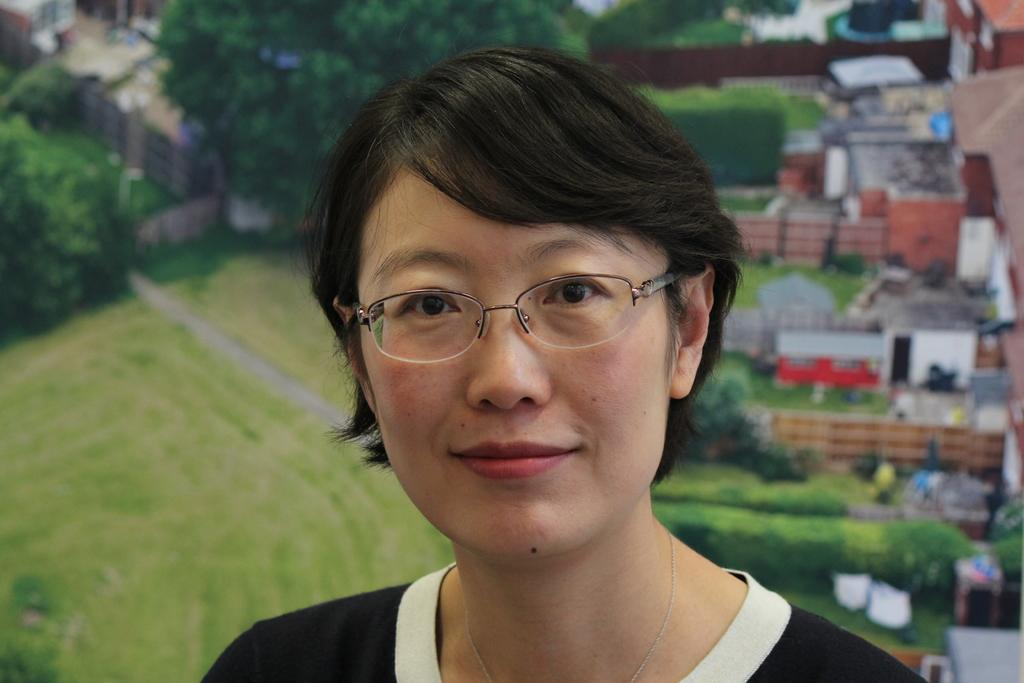Who is the main subject in the image? There is a lady in the center of the image. What can be seen on the right side of the image? There are buildings on the right side of the image. What can be seen on the left side of the image? There are buildings on the left side of the image. What type of vegetation is visible at the top side of the image? There are trees at the top side of the image. What type of soup is being served in the image? There is no soup present in the image. Can you see a monkey climbing the trees in the image? There is no monkey visible in the image; only the lady and buildings are present. 